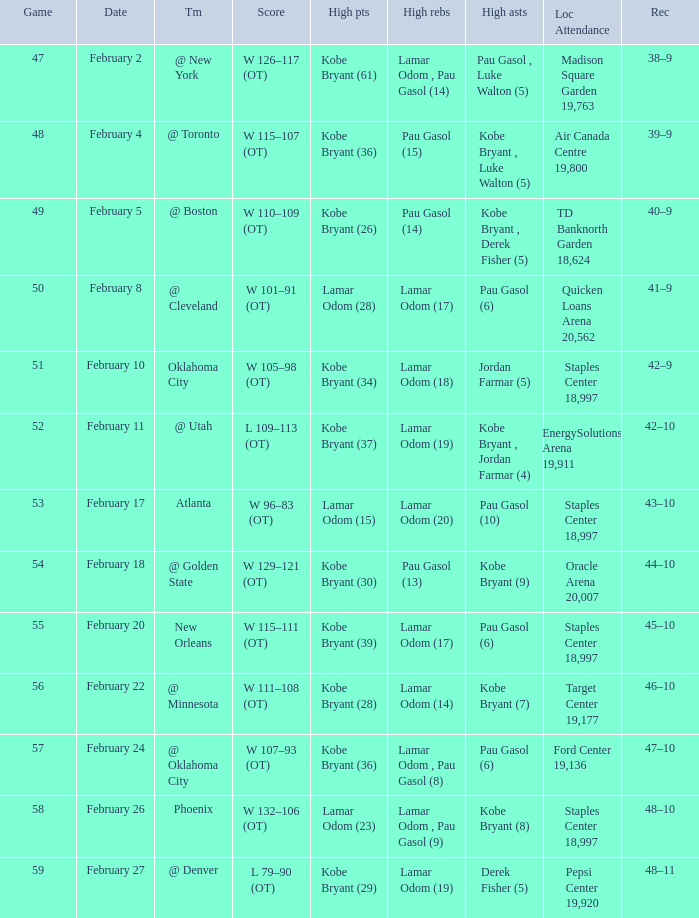Help me parse the entirety of this table. {'header': ['Game', 'Date', 'Tm', 'Score', 'High pts', 'High rebs', 'High asts', 'Loc Attendance', 'Rec'], 'rows': [['47', 'February 2', '@ New York', 'W 126–117 (OT)', 'Kobe Bryant (61)', 'Lamar Odom , Pau Gasol (14)', 'Pau Gasol , Luke Walton (5)', 'Madison Square Garden 19,763', '38–9'], ['48', 'February 4', '@ Toronto', 'W 115–107 (OT)', 'Kobe Bryant (36)', 'Pau Gasol (15)', 'Kobe Bryant , Luke Walton (5)', 'Air Canada Centre 19,800', '39–9'], ['49', 'February 5', '@ Boston', 'W 110–109 (OT)', 'Kobe Bryant (26)', 'Pau Gasol (14)', 'Kobe Bryant , Derek Fisher (5)', 'TD Banknorth Garden 18,624', '40–9'], ['50', 'February 8', '@ Cleveland', 'W 101–91 (OT)', 'Lamar Odom (28)', 'Lamar Odom (17)', 'Pau Gasol (6)', 'Quicken Loans Arena 20,562', '41–9'], ['51', 'February 10', 'Oklahoma City', 'W 105–98 (OT)', 'Kobe Bryant (34)', 'Lamar Odom (18)', 'Jordan Farmar (5)', 'Staples Center 18,997', '42–9'], ['52', 'February 11', '@ Utah', 'L 109–113 (OT)', 'Kobe Bryant (37)', 'Lamar Odom (19)', 'Kobe Bryant , Jordan Farmar (4)', 'EnergySolutions Arena 19,911', '42–10'], ['53', 'February 17', 'Atlanta', 'W 96–83 (OT)', 'Lamar Odom (15)', 'Lamar Odom (20)', 'Pau Gasol (10)', 'Staples Center 18,997', '43–10'], ['54', 'February 18', '@ Golden State', 'W 129–121 (OT)', 'Kobe Bryant (30)', 'Pau Gasol (13)', 'Kobe Bryant (9)', 'Oracle Arena 20,007', '44–10'], ['55', 'February 20', 'New Orleans', 'W 115–111 (OT)', 'Kobe Bryant (39)', 'Lamar Odom (17)', 'Pau Gasol (6)', 'Staples Center 18,997', '45–10'], ['56', 'February 22', '@ Minnesota', 'W 111–108 (OT)', 'Kobe Bryant (28)', 'Lamar Odom (14)', 'Kobe Bryant (7)', 'Target Center 19,177', '46–10'], ['57', 'February 24', '@ Oklahoma City', 'W 107–93 (OT)', 'Kobe Bryant (36)', 'Lamar Odom , Pau Gasol (8)', 'Pau Gasol (6)', 'Ford Center 19,136', '47–10'], ['58', 'February 26', 'Phoenix', 'W 132–106 (OT)', 'Lamar Odom (23)', 'Lamar Odom , Pau Gasol (9)', 'Kobe Bryant (8)', 'Staples Center 18,997', '48–10'], ['59', 'February 27', '@ Denver', 'L 79–90 (OT)', 'Kobe Bryant (29)', 'Lamar Odom (19)', 'Derek Fisher (5)', 'Pepsi Center 19,920', '48–11']]} Who had the most assists in the game against Atlanta? Pau Gasol (10). 